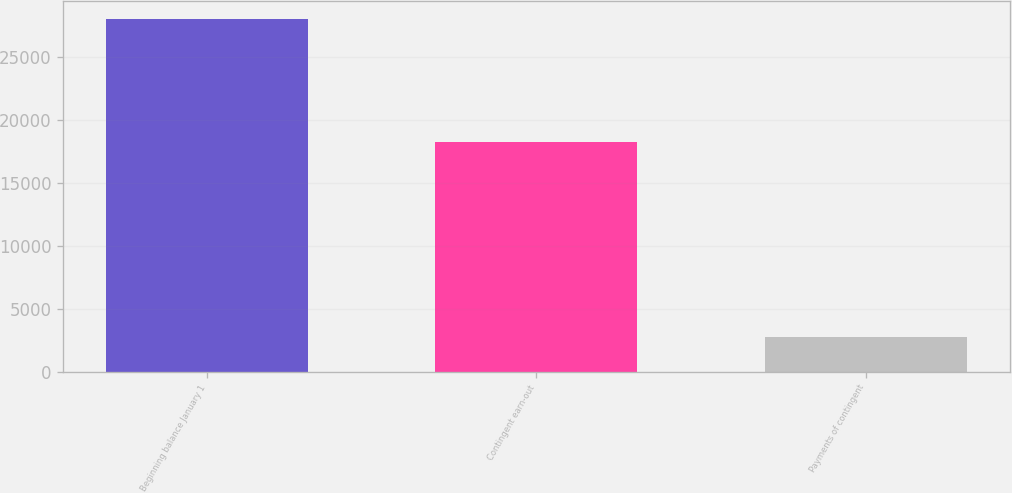Convert chart to OTSL. <chart><loc_0><loc_0><loc_500><loc_500><bar_chart><fcel>Beginning balance January 1<fcel>Contingent earn-out<fcel>Payments of contingent<nl><fcel>28058<fcel>18234<fcel>2715<nl></chart> 